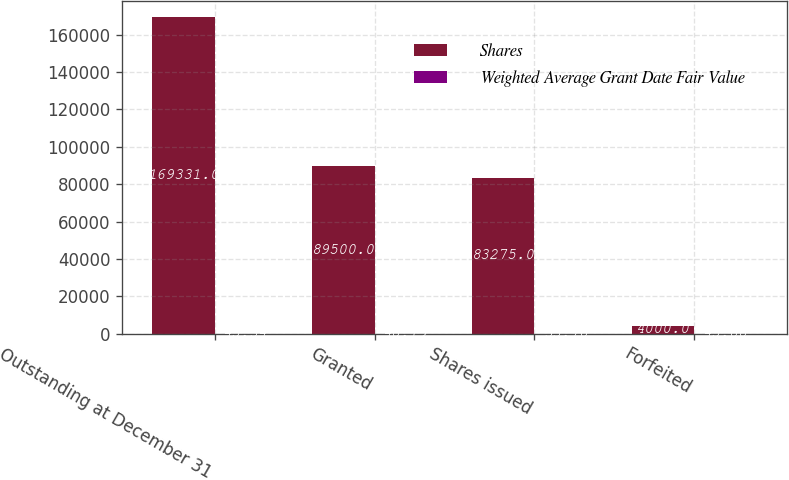Convert chart to OTSL. <chart><loc_0><loc_0><loc_500><loc_500><stacked_bar_chart><ecel><fcel>Outstanding at December 31<fcel>Granted<fcel>Shares issued<fcel>Forfeited<nl><fcel>Shares<fcel>169331<fcel>89500<fcel>83275<fcel>4000<nl><fcel>Weighted Average Grant Date Fair Value<fcel>45.34<fcel>48.19<fcel>33.78<fcel>45.88<nl></chart> 